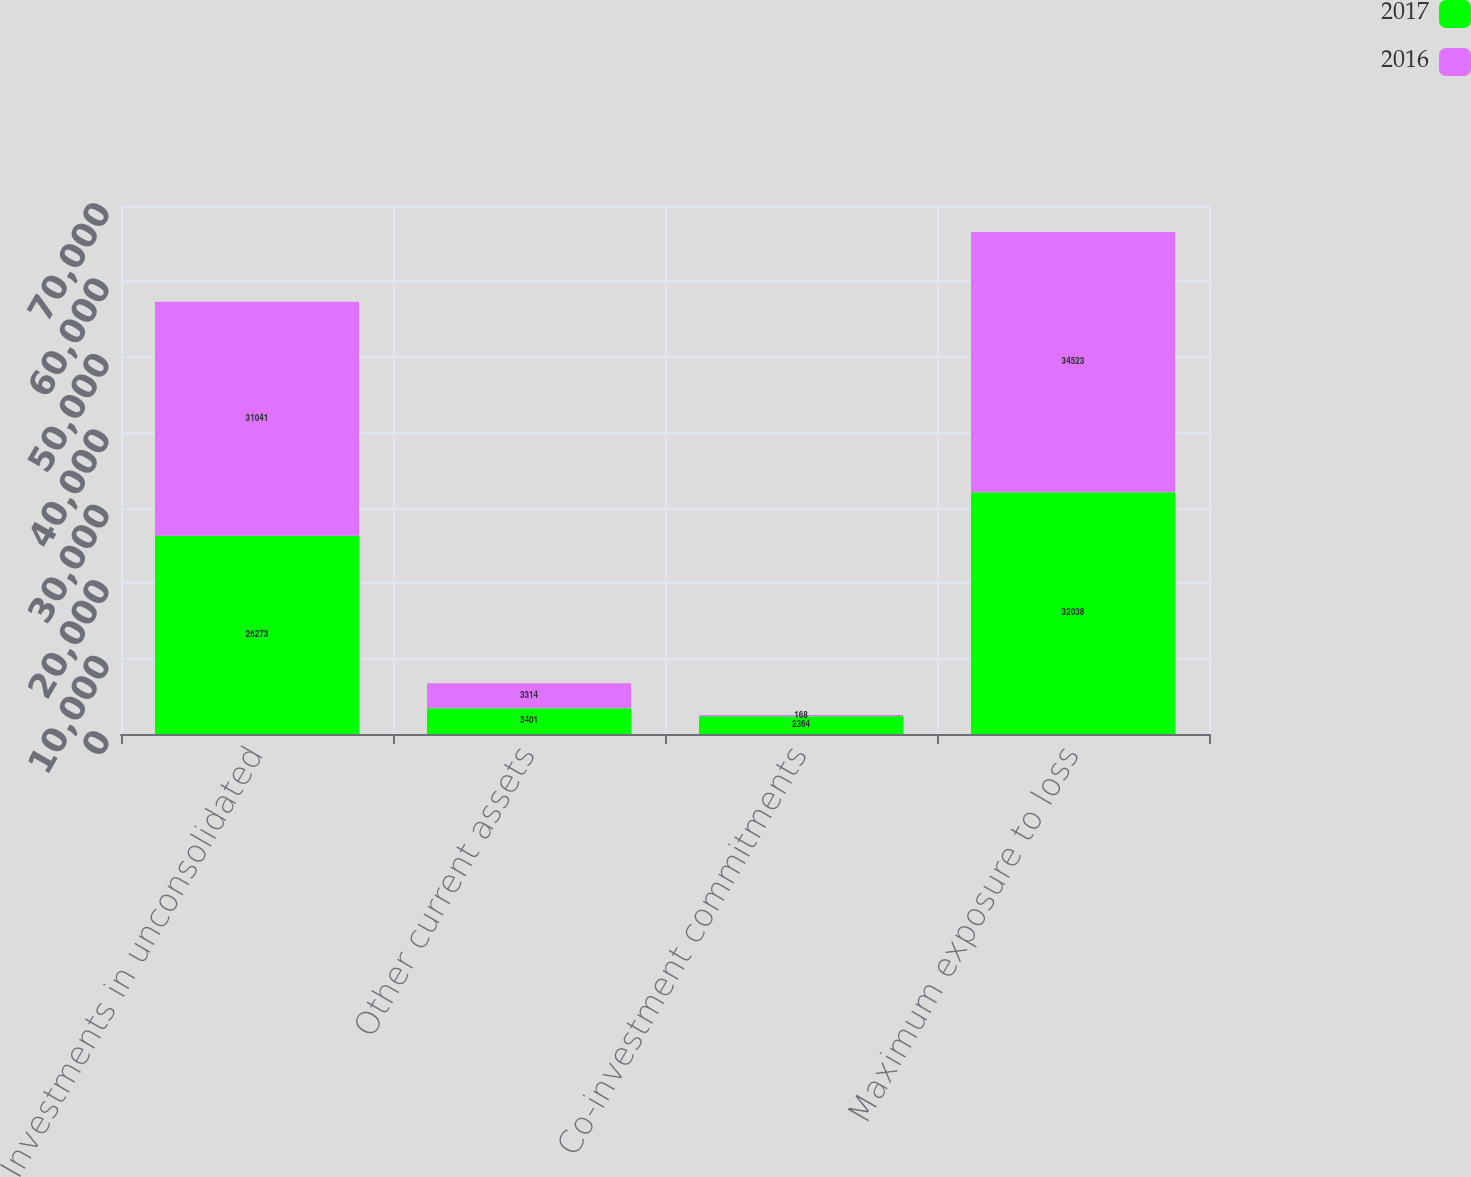<chart> <loc_0><loc_0><loc_500><loc_500><stacked_bar_chart><ecel><fcel>Investments in unconsolidated<fcel>Other current assets<fcel>Co-investment commitments<fcel>Maximum exposure to loss<nl><fcel>2017<fcel>26273<fcel>3401<fcel>2364<fcel>32038<nl><fcel>2016<fcel>31041<fcel>3314<fcel>168<fcel>34523<nl></chart> 